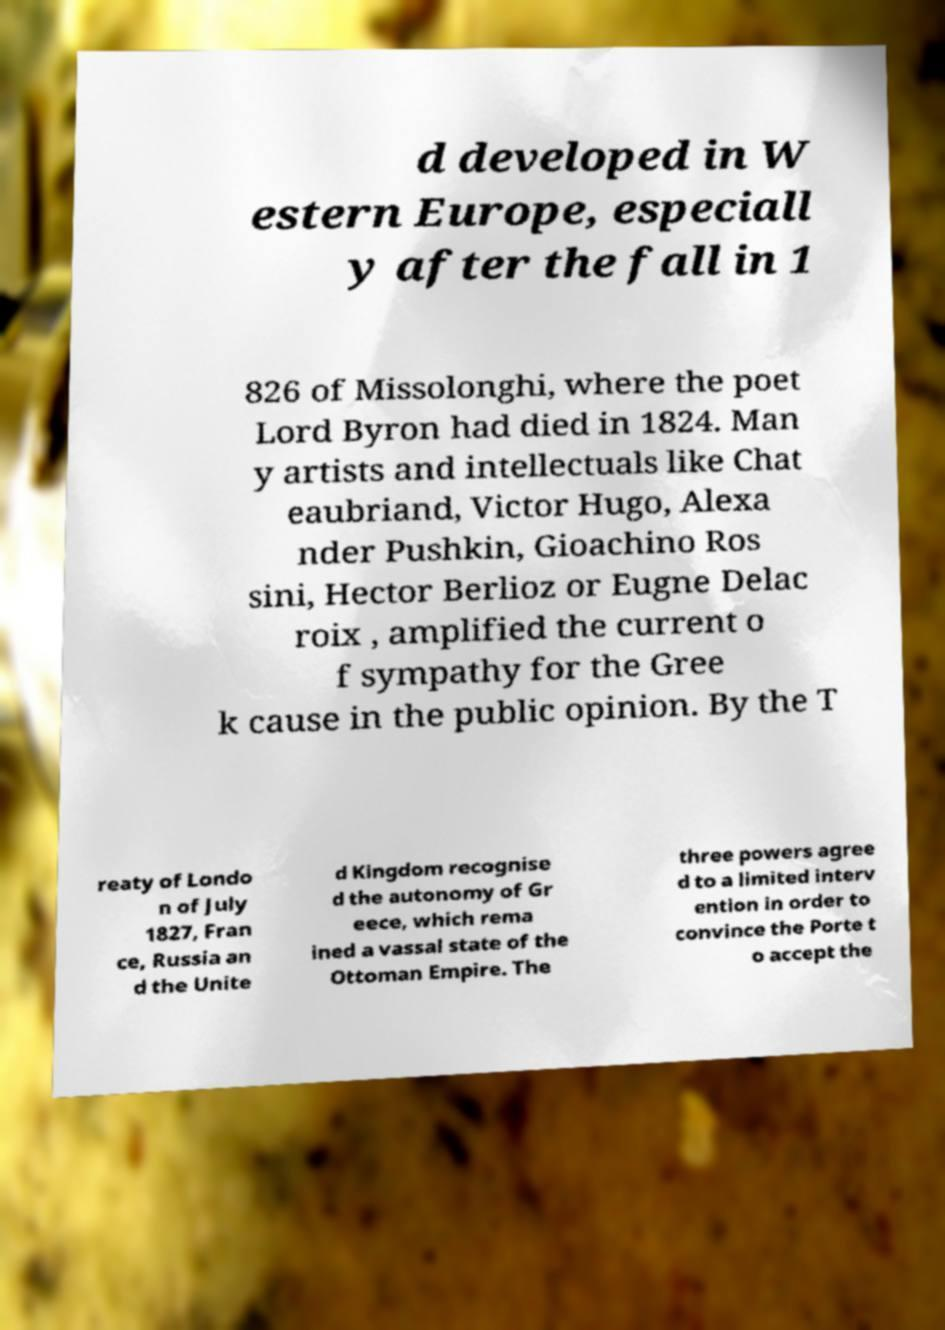Please identify and transcribe the text found in this image. d developed in W estern Europe, especiall y after the fall in 1 826 of Missolonghi, where the poet Lord Byron had died in 1824. Man y artists and intellectuals like Chat eaubriand, Victor Hugo, Alexa nder Pushkin, Gioachino Ros sini, Hector Berlioz or Eugne Delac roix , amplified the current o f sympathy for the Gree k cause in the public opinion. By the T reaty of Londo n of July 1827, Fran ce, Russia an d the Unite d Kingdom recognise d the autonomy of Gr eece, which rema ined a vassal state of the Ottoman Empire. The three powers agree d to a limited interv ention in order to convince the Porte t o accept the 